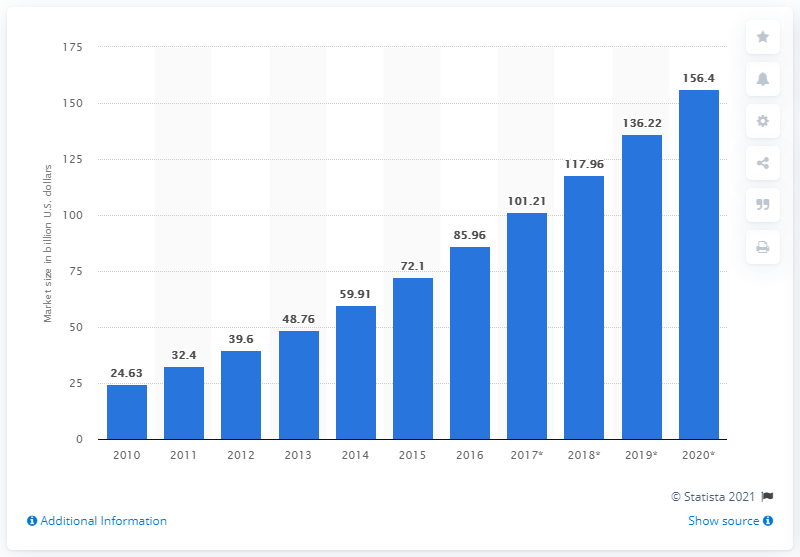Highlight a few significant elements in this photo. The market for cloud computing and hosting services is estimated to be worth $117.96. 